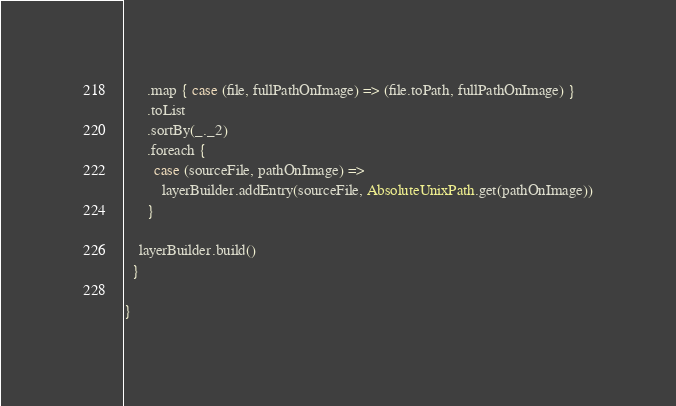<code> <loc_0><loc_0><loc_500><loc_500><_Scala_>      .map { case (file, fullPathOnImage) => (file.toPath, fullPathOnImage) }
      .toList
      .sortBy(_._2)
      .foreach {
        case (sourceFile, pathOnImage) =>
          layerBuilder.addEntry(sourceFile, AbsoluteUnixPath.get(pathOnImage))
      }

    layerBuilder.build()
  }

}
</code> 